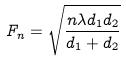<formula> <loc_0><loc_0><loc_500><loc_500>F _ { n } = \sqrt { \frac { n \lambda d _ { 1 } d _ { 2 } } { d _ { 1 } + d _ { 2 } } }</formula> 